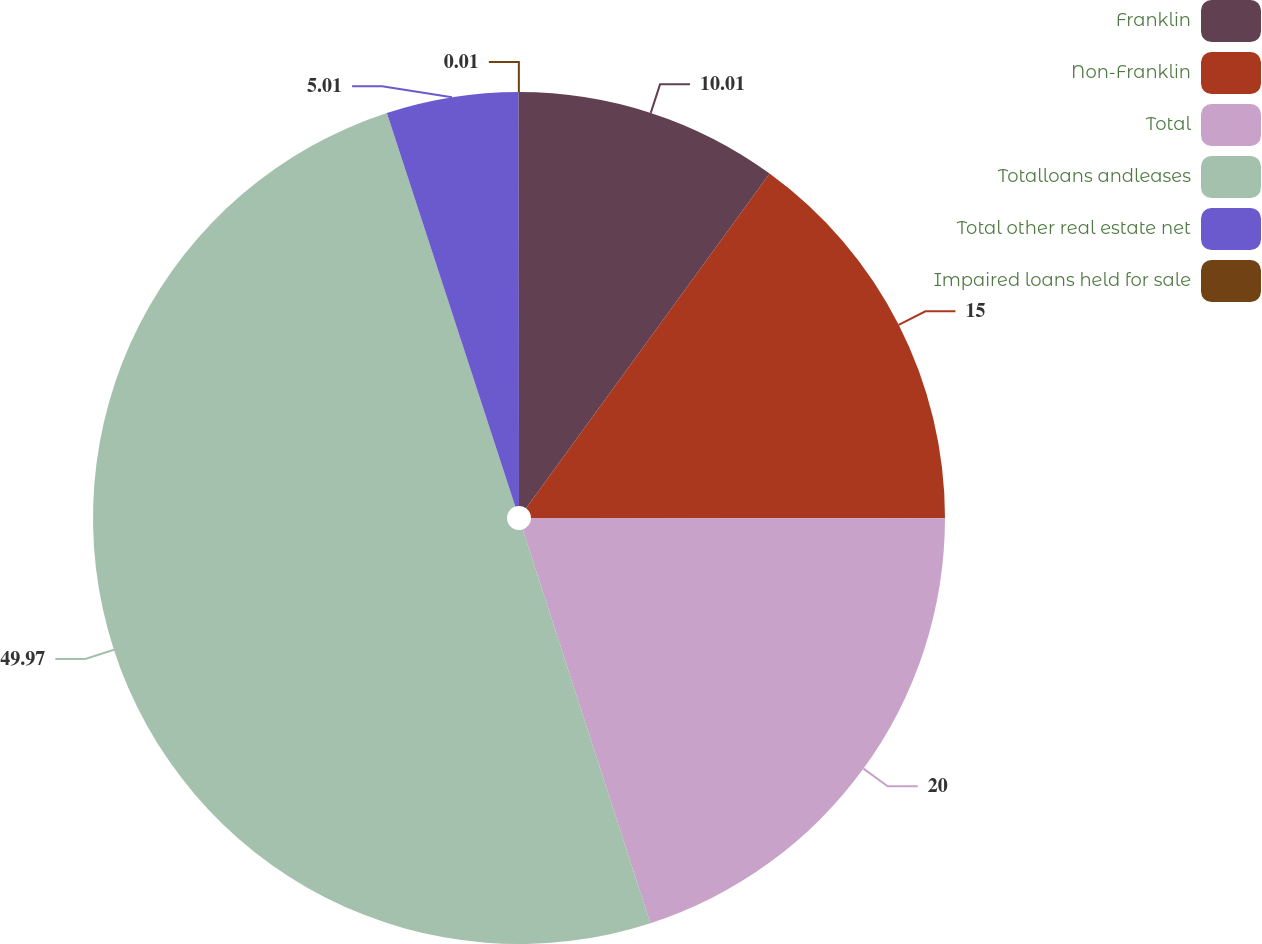Convert chart. <chart><loc_0><loc_0><loc_500><loc_500><pie_chart><fcel>Franklin<fcel>Non-Franklin<fcel>Total<fcel>Totalloans andleases<fcel>Total other real estate net<fcel>Impaired loans held for sale<nl><fcel>10.01%<fcel>15.0%<fcel>20.0%<fcel>49.97%<fcel>5.01%<fcel>0.01%<nl></chart> 